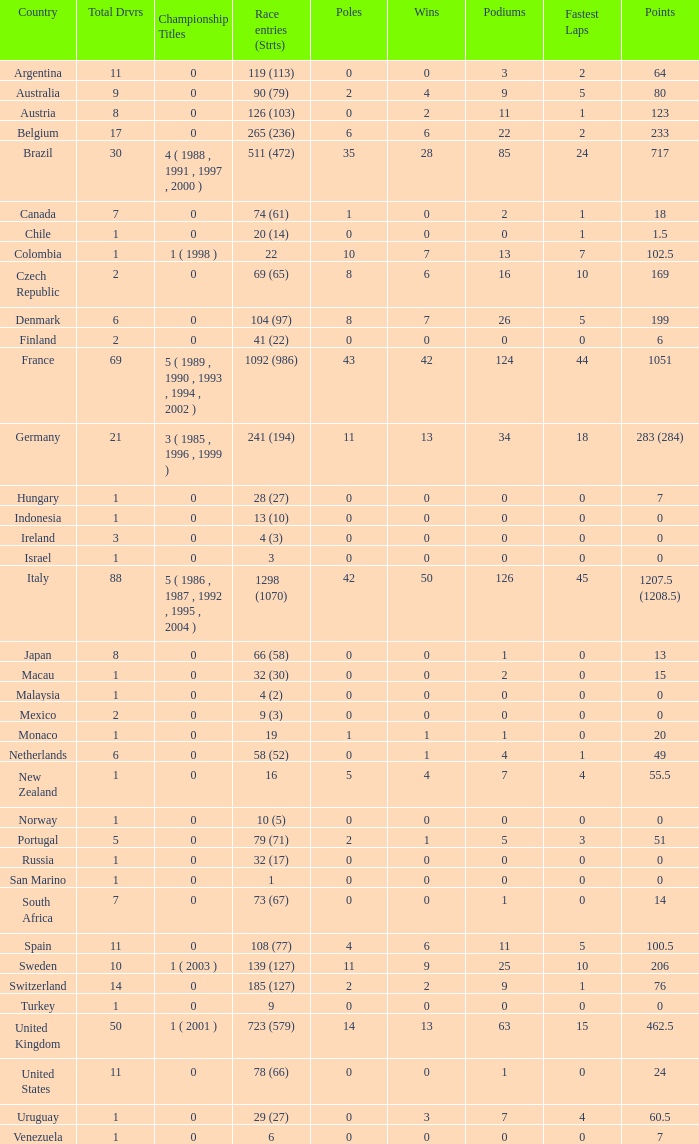Could you parse the entire table as a dict? {'header': ['Country', 'Total Drvrs', 'Championship Titles', 'Race entries (Strts)', 'Poles', 'Wins', 'Podiums', 'Fastest Laps', 'Points'], 'rows': [['Argentina', '11', '0', '119 (113)', '0', '0', '3', '2', '64'], ['Australia', '9', '0', '90 (79)', '2', '4', '9', '5', '80'], ['Austria', '8', '0', '126 (103)', '0', '2', '11', '1', '123'], ['Belgium', '17', '0', '265 (236)', '6', '6', '22', '2', '233'], ['Brazil', '30', '4 ( 1988 , 1991 , 1997 , 2000 )', '511 (472)', '35', '28', '85', '24', '717'], ['Canada', '7', '0', '74 (61)', '1', '0', '2', '1', '18'], ['Chile', '1', '0', '20 (14)', '0', '0', '0', '1', '1.5'], ['Colombia', '1', '1 ( 1998 )', '22', '10', '7', '13', '7', '102.5'], ['Czech Republic', '2', '0', '69 (65)', '8', '6', '16', '10', '169'], ['Denmark', '6', '0', '104 (97)', '8', '7', '26', '5', '199'], ['Finland', '2', '0', '41 (22)', '0', '0', '0', '0', '6'], ['France', '69', '5 ( 1989 , 1990 , 1993 , 1994 , 2002 )', '1092 (986)', '43', '42', '124', '44', '1051'], ['Germany', '21', '3 ( 1985 , 1996 , 1999 )', '241 (194)', '11', '13', '34', '18', '283 (284)'], ['Hungary', '1', '0', '28 (27)', '0', '0', '0', '0', '7'], ['Indonesia', '1', '0', '13 (10)', '0', '0', '0', '0', '0'], ['Ireland', '3', '0', '4 (3)', '0', '0', '0', '0', '0'], ['Israel', '1', '0', '3', '0', '0', '0', '0', '0'], ['Italy', '88', '5 ( 1986 , 1987 , 1992 , 1995 , 2004 )', '1298 (1070)', '42', '50', '126', '45', '1207.5 (1208.5)'], ['Japan', '8', '0', '66 (58)', '0', '0', '1', '0', '13'], ['Macau', '1', '0', '32 (30)', '0', '0', '2', '0', '15'], ['Malaysia', '1', '0', '4 (2)', '0', '0', '0', '0', '0'], ['Mexico', '2', '0', '9 (3)', '0', '0', '0', '0', '0'], ['Monaco', '1', '0', '19', '1', '1', '1', '0', '20'], ['Netherlands', '6', '0', '58 (52)', '0', '1', '4', '1', '49'], ['New Zealand', '1', '0', '16', '5', '4', '7', '4', '55.5'], ['Norway', '1', '0', '10 (5)', '0', '0', '0', '0', '0'], ['Portugal', '5', '0', '79 (71)', '2', '1', '5', '3', '51'], ['Russia', '1', '0', '32 (17)', '0', '0', '0', '0', '0'], ['San Marino', '1', '0', '1', '0', '0', '0', '0', '0'], ['South Africa', '7', '0', '73 (67)', '0', '0', '1', '0', '14'], ['Spain', '11', '0', '108 (77)', '4', '6', '11', '5', '100.5'], ['Sweden', '10', '1 ( 2003 )', '139 (127)', '11', '9', '25', '10', '206'], ['Switzerland', '14', '0', '185 (127)', '2', '2', '9', '1', '76'], ['Turkey', '1', '0', '9', '0', '0', '0', '0', '0'], ['United Kingdom', '50', '1 ( 2001 )', '723 (579)', '14', '13', '63', '15', '462.5'], ['United States', '11', '0', '78 (66)', '0', '0', '1', '0', '24'], ['Uruguay', '1', '0', '29 (27)', '0', '3', '7', '4', '60.5'], ['Venezuela', '1', '0', '6', '0', '0', '0', '0', '7']]} How many titles for the nation with less than 3 fastest laps and 22 podiums? 0.0. 